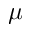Convert formula to latex. <formula><loc_0><loc_0><loc_500><loc_500>\mu</formula> 